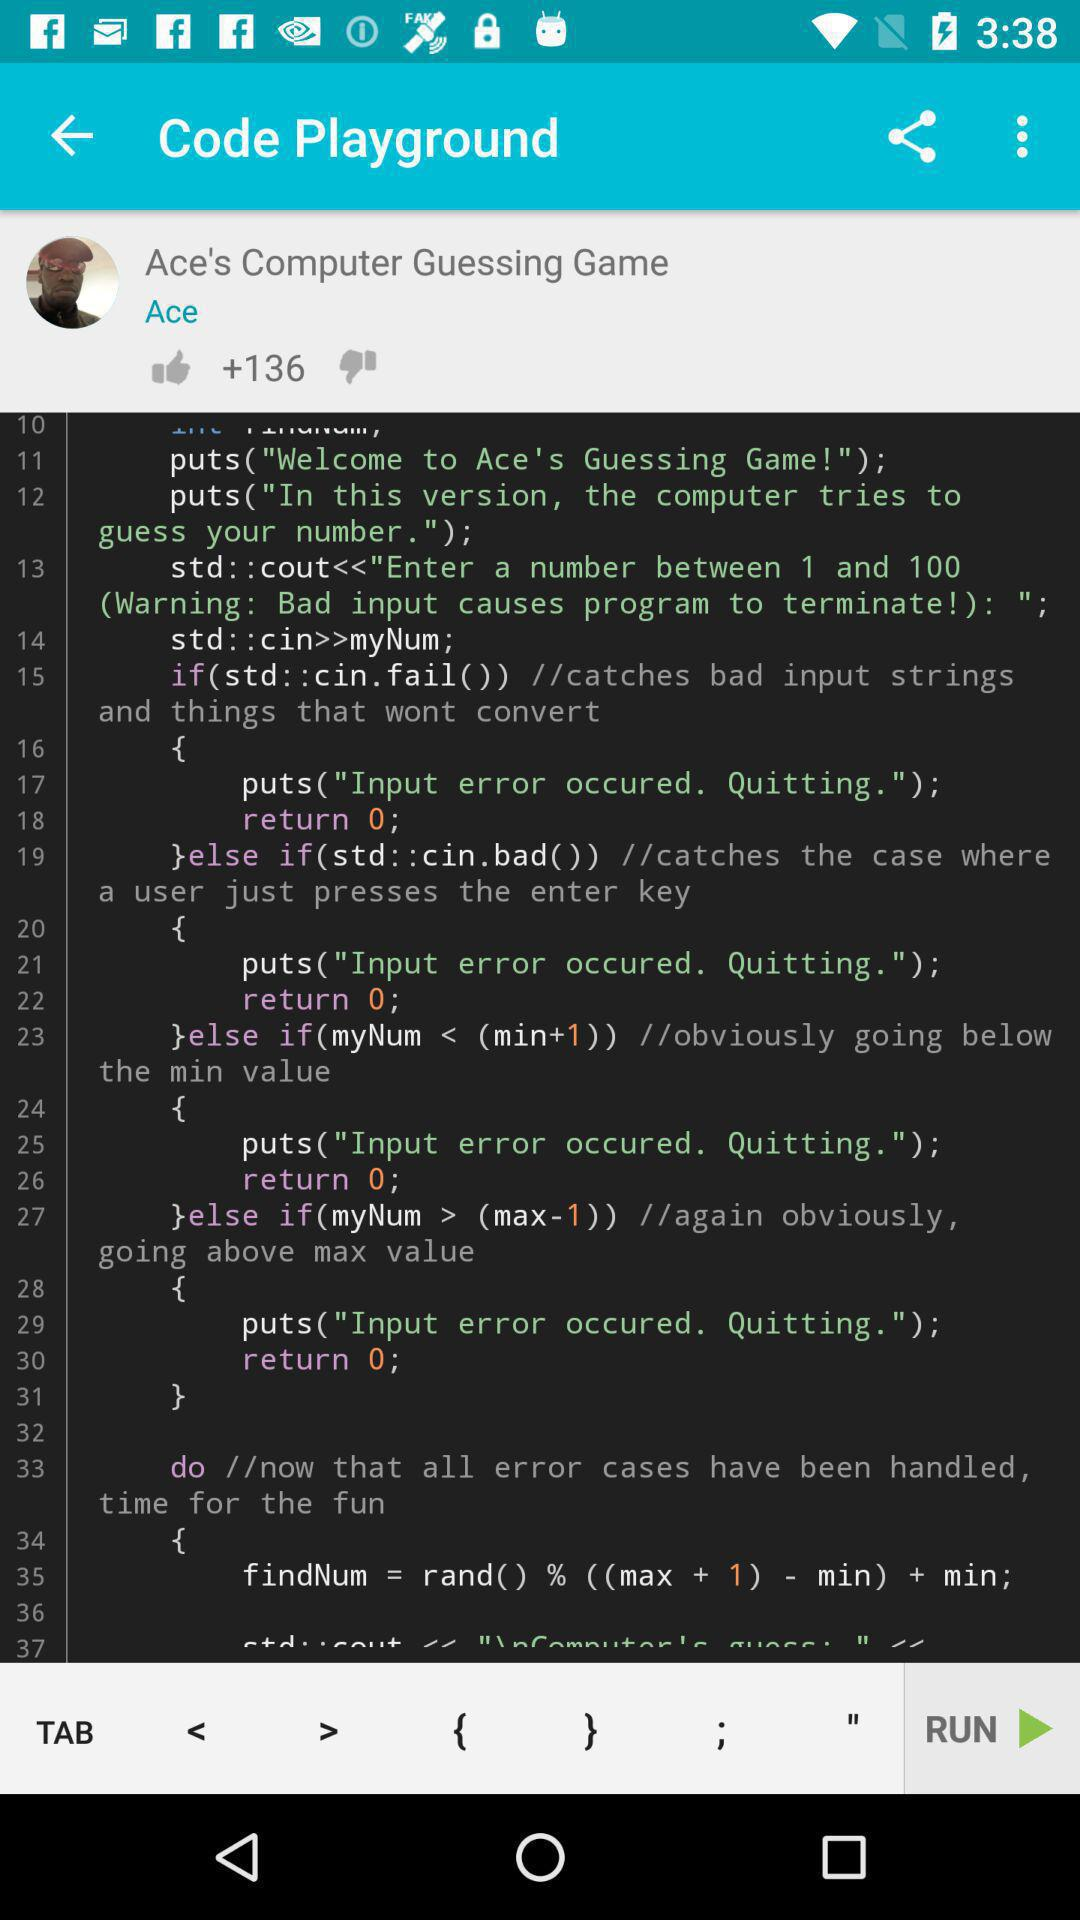What is the user name? The user name is Ace. 